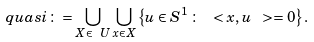<formula> <loc_0><loc_0><loc_500><loc_500>\ q u a s i \colon = \bigcup _ { X \in \ U } \bigcup _ { x \in X } \left \{ u \in S ^ { 1 } \, \colon \, \ < x , u \ > = 0 \right \} .</formula> 